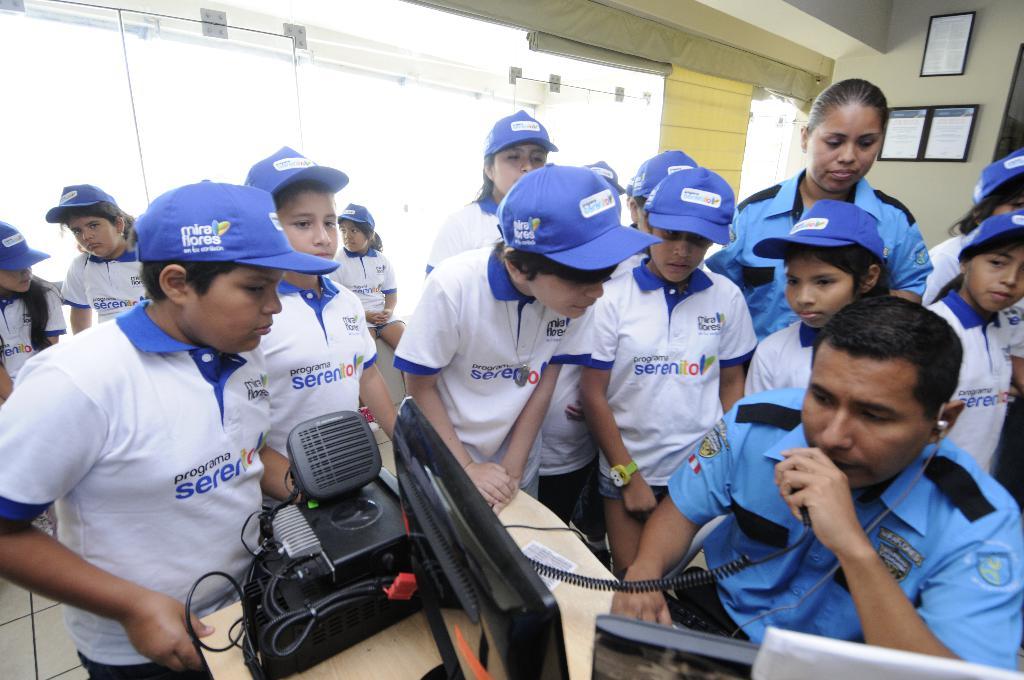What is written in front of all tshirts?
Keep it short and to the point. Serenito. 